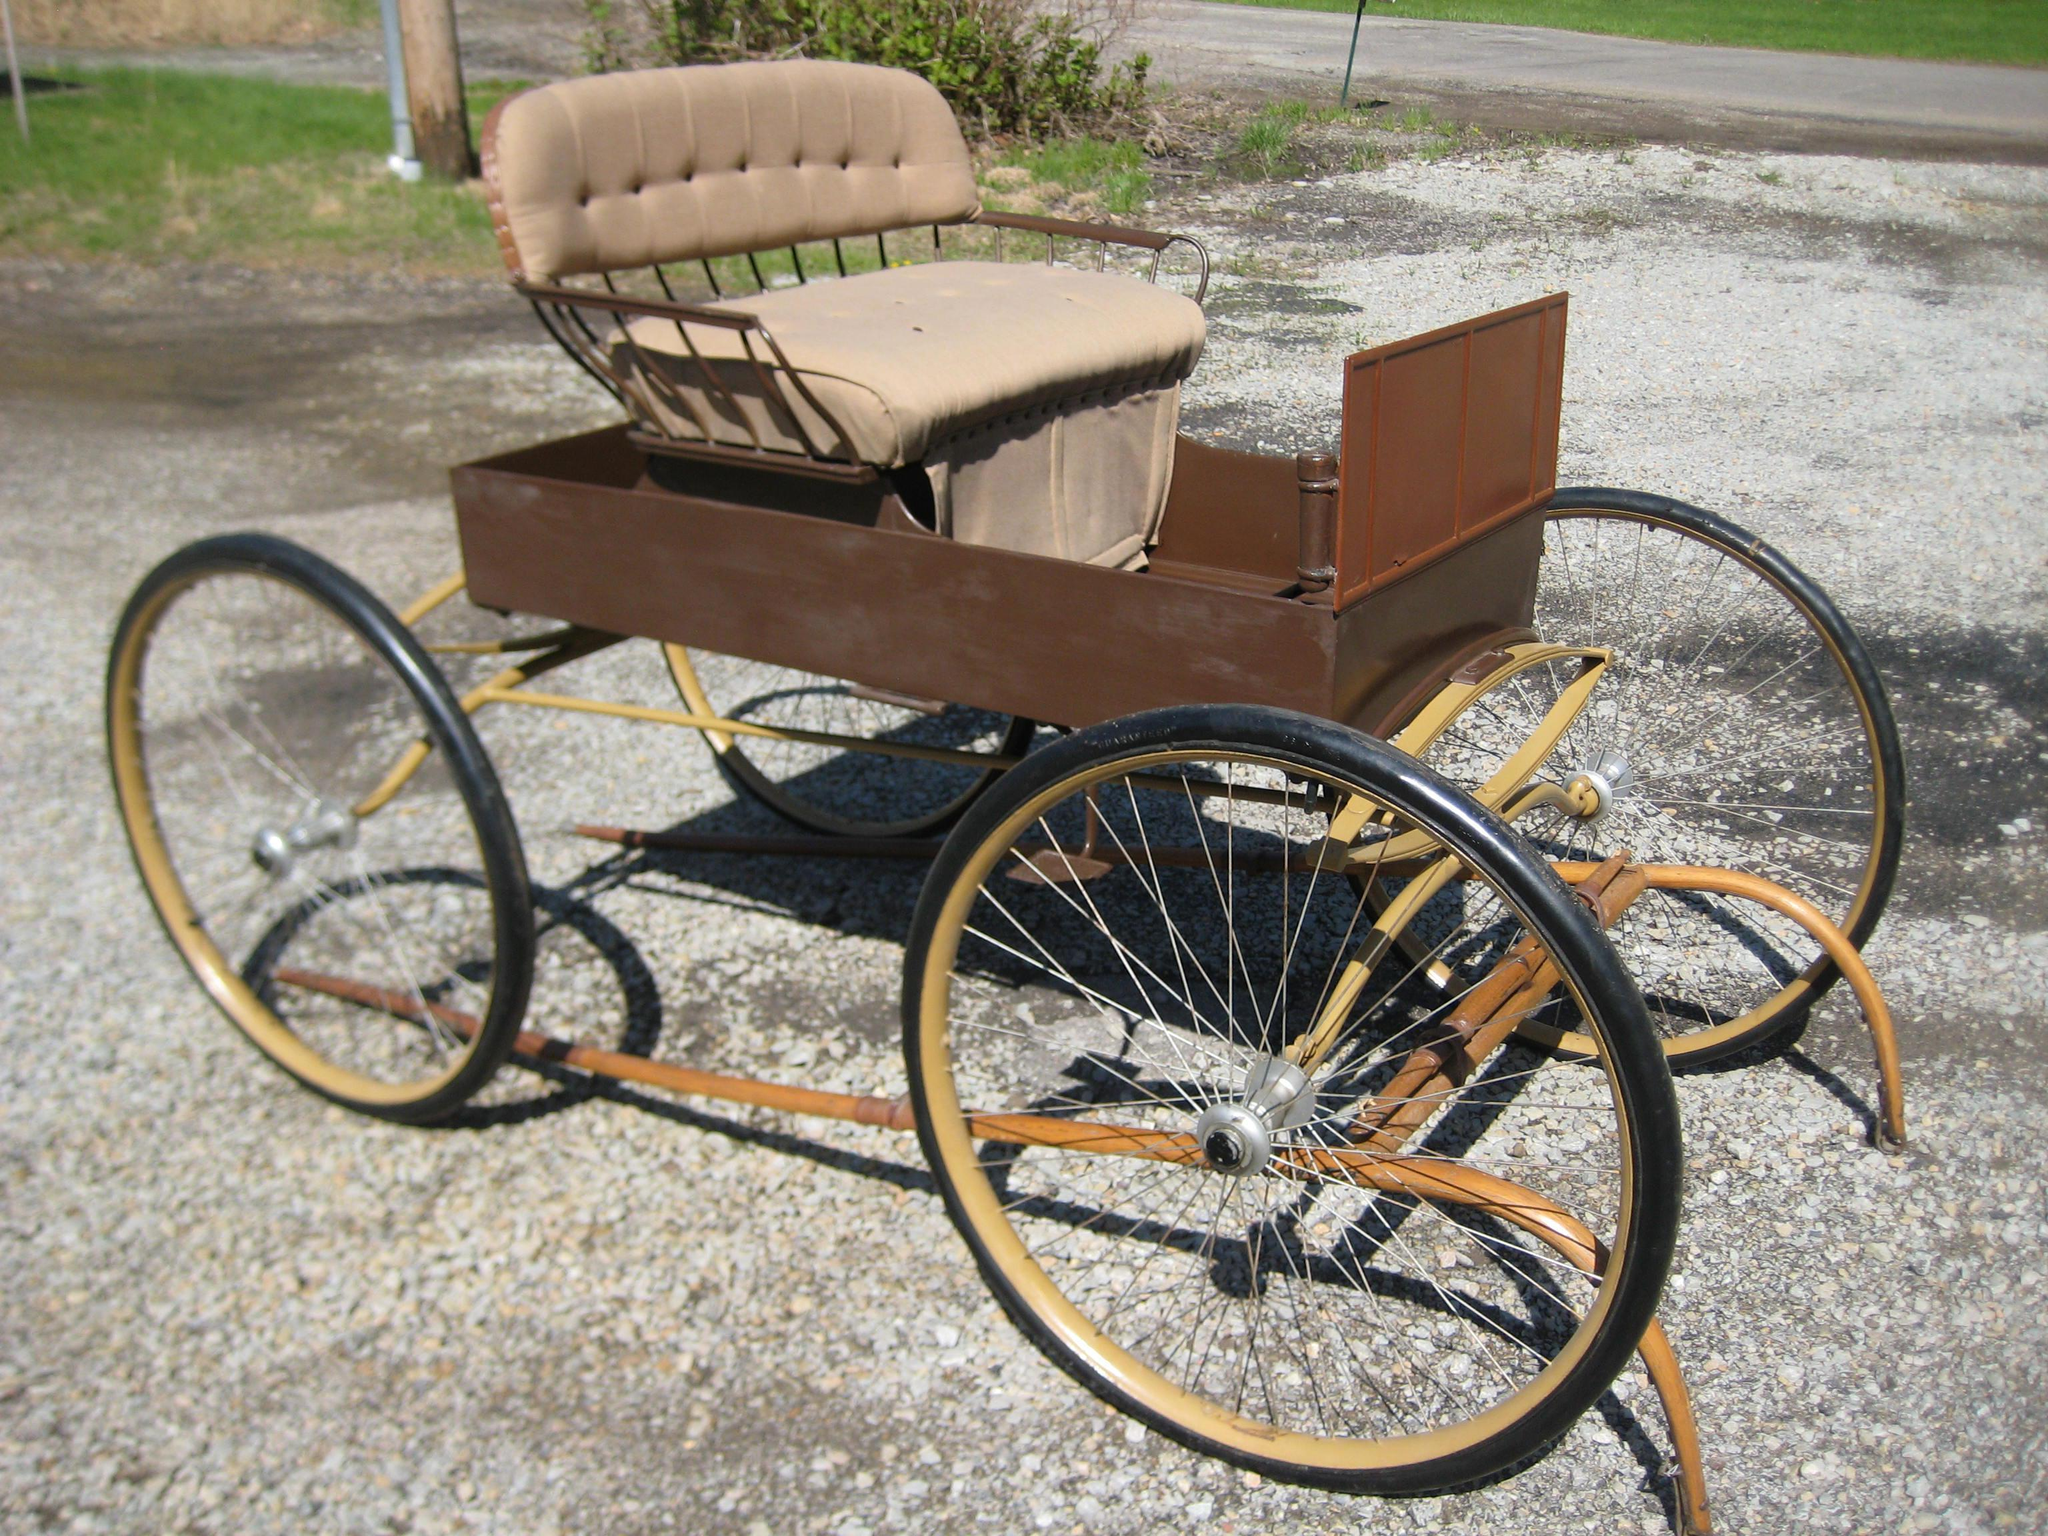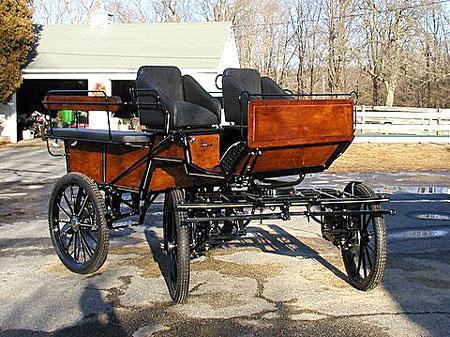The first image is the image on the left, the second image is the image on the right. For the images displayed, is the sentence "An image shows a buggy with treaded rubber tires." factually correct? Answer yes or no. Yes. 